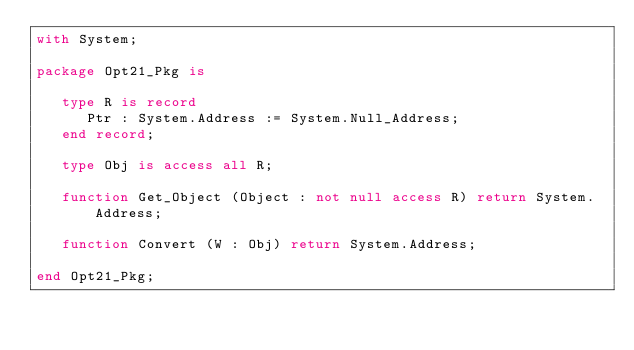<code> <loc_0><loc_0><loc_500><loc_500><_Ada_>with System;

package Opt21_Pkg is

   type R is record
      Ptr : System.Address := System.Null_Address;
   end record;

   type Obj is access all R;

   function Get_Object (Object : not null access R) return System.Address;

   function Convert (W : Obj) return System.Address;

end Opt21_Pkg;
</code> 